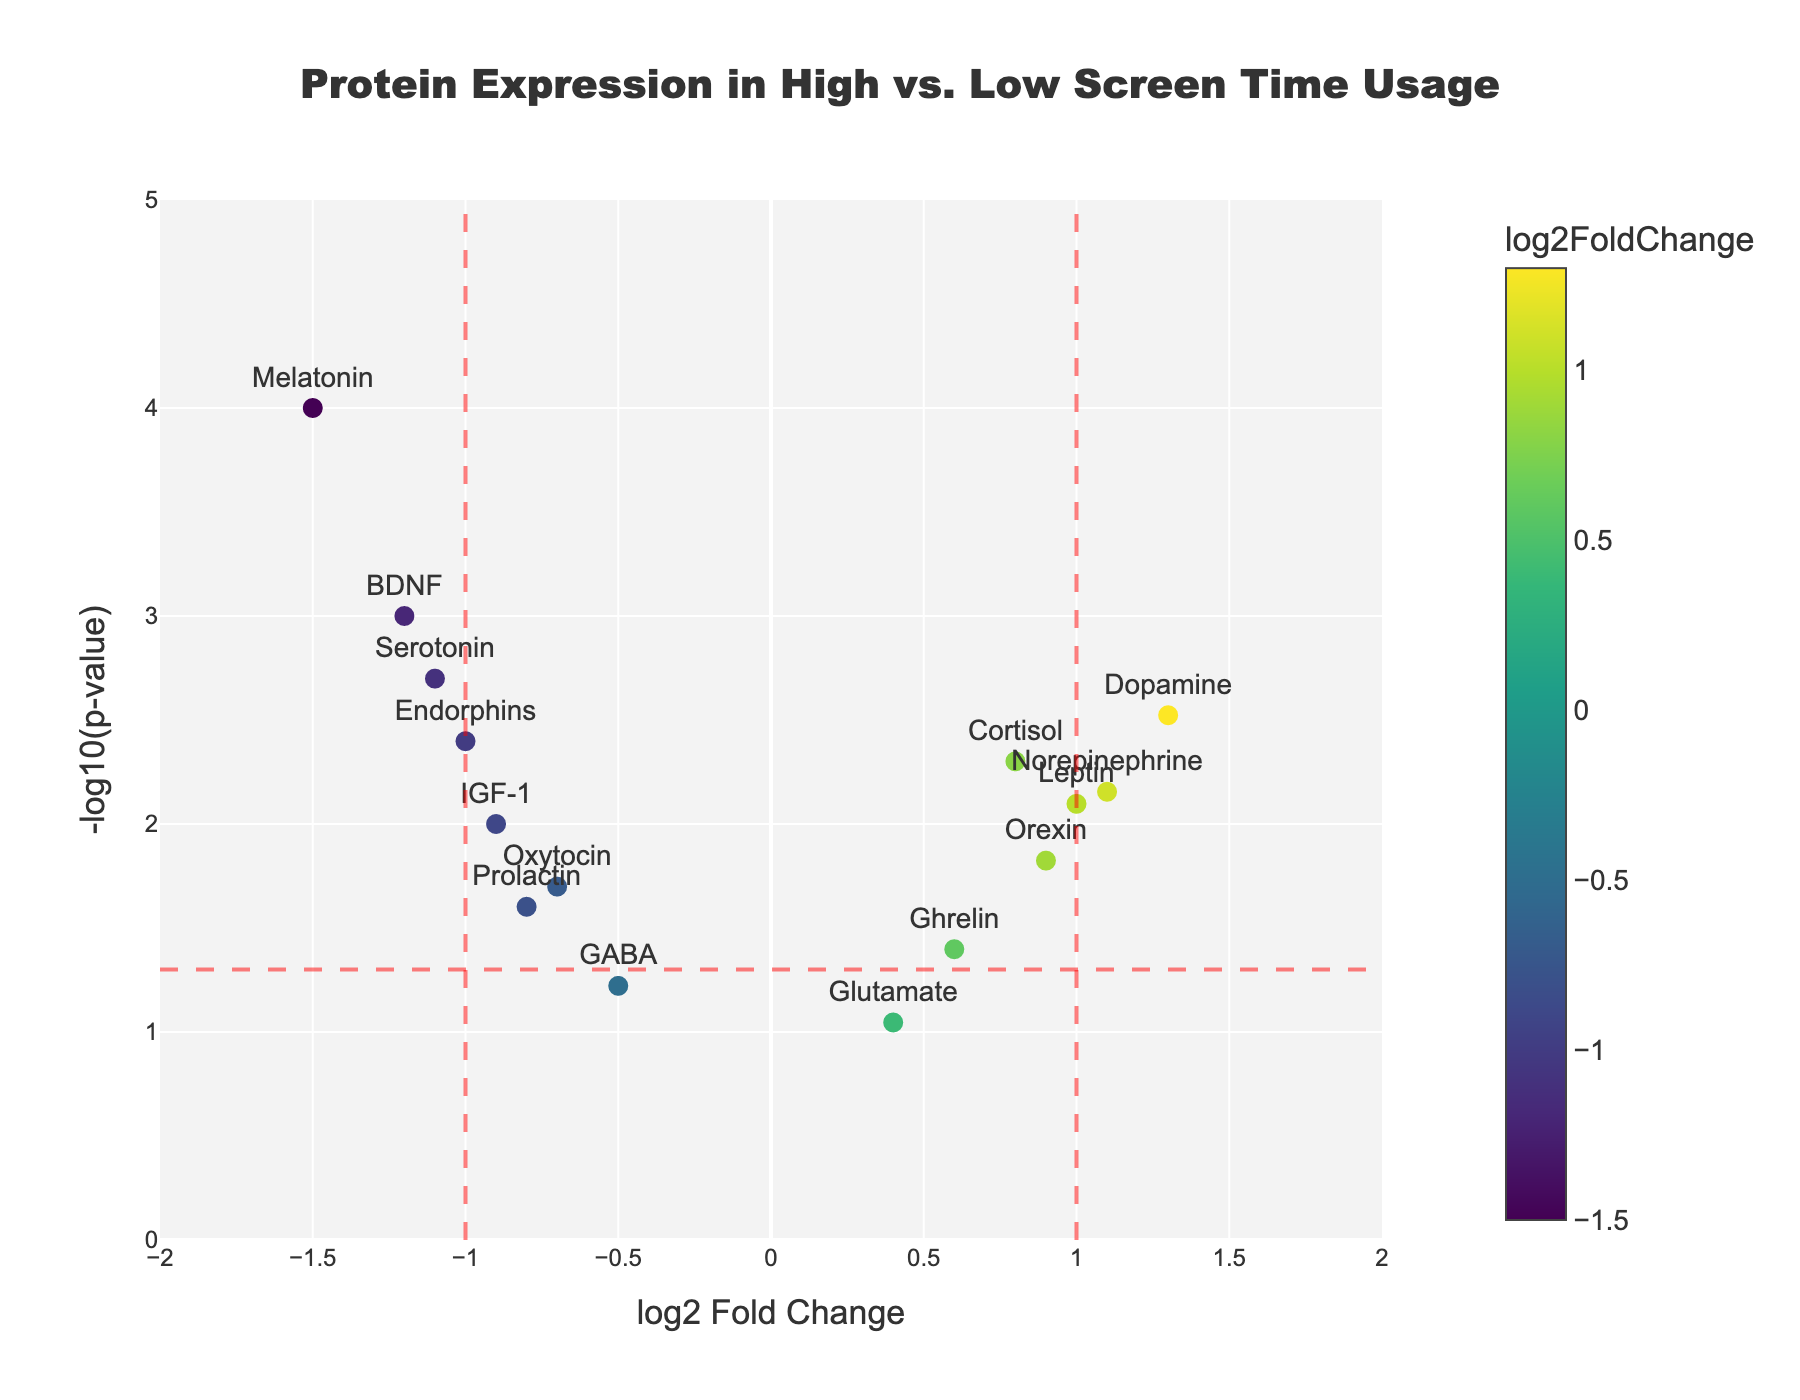How many proteins have a log2FoldChange greater than 1 or less than -1? Visualize the data points with log2FoldChange values on the x-axis and count those where the points fall to the right of 1 or to the left of -1.
Answer: 6 Which protein has the highest log2FoldChange? Identify the protein with the furthest positive x-axis value. In the figure, Dopamine has the highest log2FoldChange of 1.3.
Answer: Dopamine Which protein has the lowest p-value? Check the vertical (y-axis) values and find the protein with the highest -log10(p-value) value. Melatonin has the highest -log10(p-value), indicating the lowest p-value.
Answer: Melatonin How many proteins are statistically significant (p-value < 0.05)? Evaluate the data points above the horizontal line for -log10(p-value) = 1.3 (which translates to p-value < 0.05). Count the proteins that are above this threshold.
Answer: 11 Which proteins have a log2FoldChange less than -1? Look for the data points that lie to the left of -1 on the x-axis and identify the corresponding proteins.
Answer: BDNF, Melatonin, Serotonin What is the log2FoldChange and p-value for Endorphins? Use hovertext or the specified protein's position in the figure to find its coordinates: Endorphins is at -1.0 on the x-axis and -log10(0.004) on the y-axis.
Answer: log2FoldChange: -1.0, p-value: 0.004 What is the log2FoldChange value range of the proteins? Observe the minimum and maximum x-axis values for the data points. The minimum log2FoldChange is -1.5, and the maximum is 1.3.
Answer: Range: -1.5 to 1.3 Which protein has the smallest log2FoldChange but is still statistically significant? Find the smallest x-axis absolute values greater than 1 or less than -1, with -log10(p-value) above 1.3. Oxytocin has the smallest log2FoldChange of -0.7 but is significant.
Answer: Oxytocin 